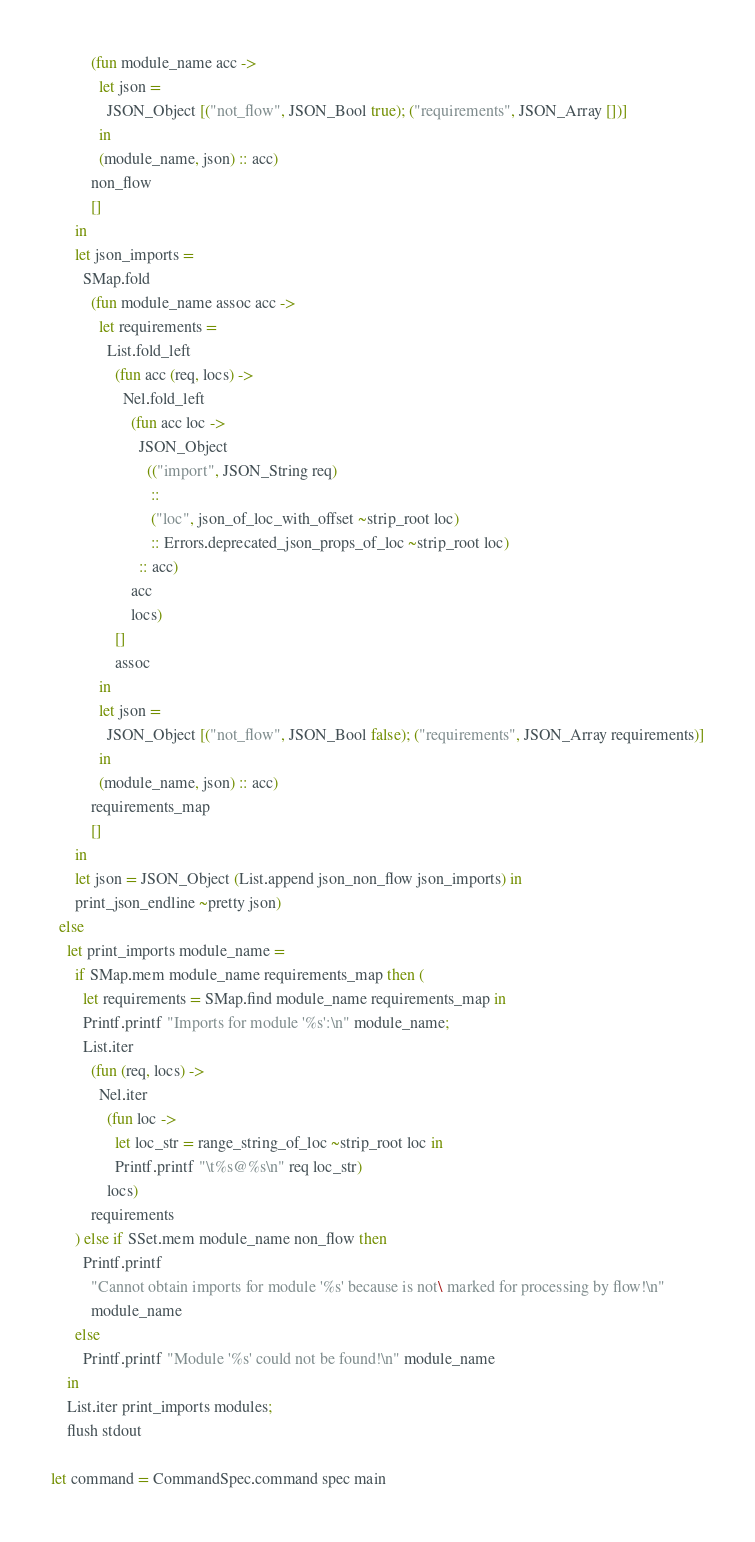Convert code to text. <code><loc_0><loc_0><loc_500><loc_500><_OCaml_>          (fun module_name acc ->
            let json =
              JSON_Object [("not_flow", JSON_Bool true); ("requirements", JSON_Array [])]
            in
            (module_name, json) :: acc)
          non_flow
          []
      in
      let json_imports =
        SMap.fold
          (fun module_name assoc acc ->
            let requirements =
              List.fold_left
                (fun acc (req, locs) ->
                  Nel.fold_left
                    (fun acc loc ->
                      JSON_Object
                        (("import", JSON_String req)
                         ::
                         ("loc", json_of_loc_with_offset ~strip_root loc)
                         :: Errors.deprecated_json_props_of_loc ~strip_root loc)
                      :: acc)
                    acc
                    locs)
                []
                assoc
            in
            let json =
              JSON_Object [("not_flow", JSON_Bool false); ("requirements", JSON_Array requirements)]
            in
            (module_name, json) :: acc)
          requirements_map
          []
      in
      let json = JSON_Object (List.append json_non_flow json_imports) in
      print_json_endline ~pretty json)
  else
    let print_imports module_name =
      if SMap.mem module_name requirements_map then (
        let requirements = SMap.find module_name requirements_map in
        Printf.printf "Imports for module '%s':\n" module_name;
        List.iter
          (fun (req, locs) ->
            Nel.iter
              (fun loc ->
                let loc_str = range_string_of_loc ~strip_root loc in
                Printf.printf "\t%s@%s\n" req loc_str)
              locs)
          requirements
      ) else if SSet.mem module_name non_flow then
        Printf.printf
          "Cannot obtain imports for module '%s' because is not\ marked for processing by flow!\n"
          module_name
      else
        Printf.printf "Module '%s' could not be found!\n" module_name
    in
    List.iter print_imports modules;
    flush stdout

let command = CommandSpec.command spec main
</code> 